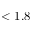Convert formula to latex. <formula><loc_0><loc_0><loc_500><loc_500>< 1 . 8</formula> 